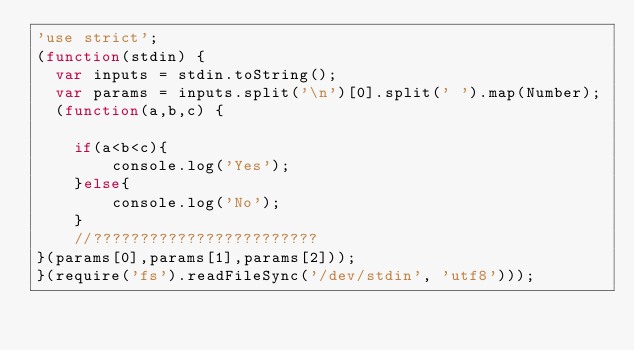Convert code to text. <code><loc_0><loc_0><loc_500><loc_500><_JavaScript_>'use strict';
(function(stdin) { 
  var inputs = stdin.toString();
  var params = inputs.split('\n')[0].split(' ').map(Number);
  (function(a,b,c) {

    if(a<b<c){
        console.log('Yes');
    }else{
        console.log('No');
    }
    //????????????????????????
}(params[0],params[1],params[2])); 
}(require('fs').readFileSync('/dev/stdin', 'utf8')));</code> 